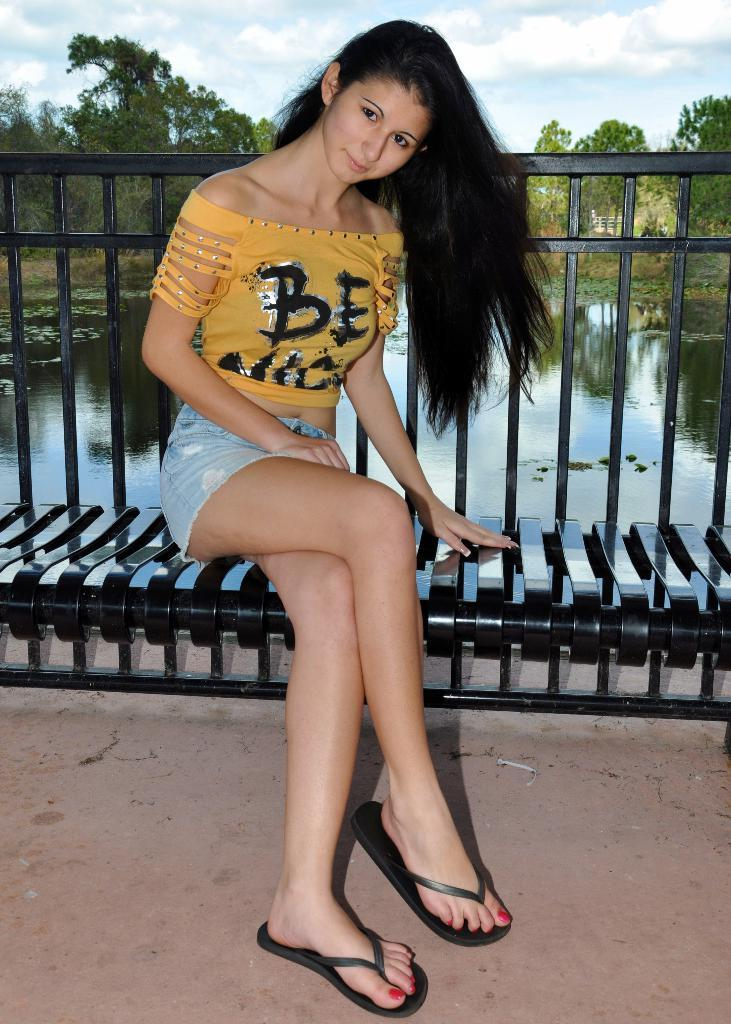Who is present in the image? There is a woman in the image. What is the woman doing in the image? The woman is sitting on a bench. Where is the bench located? The bench is on the ground. What can be seen in the background of the image? There is water, trees, and the sky visible in the background of the image. What type of mint is growing on the lamp in the image? There is no mint or lamp present in the image. 